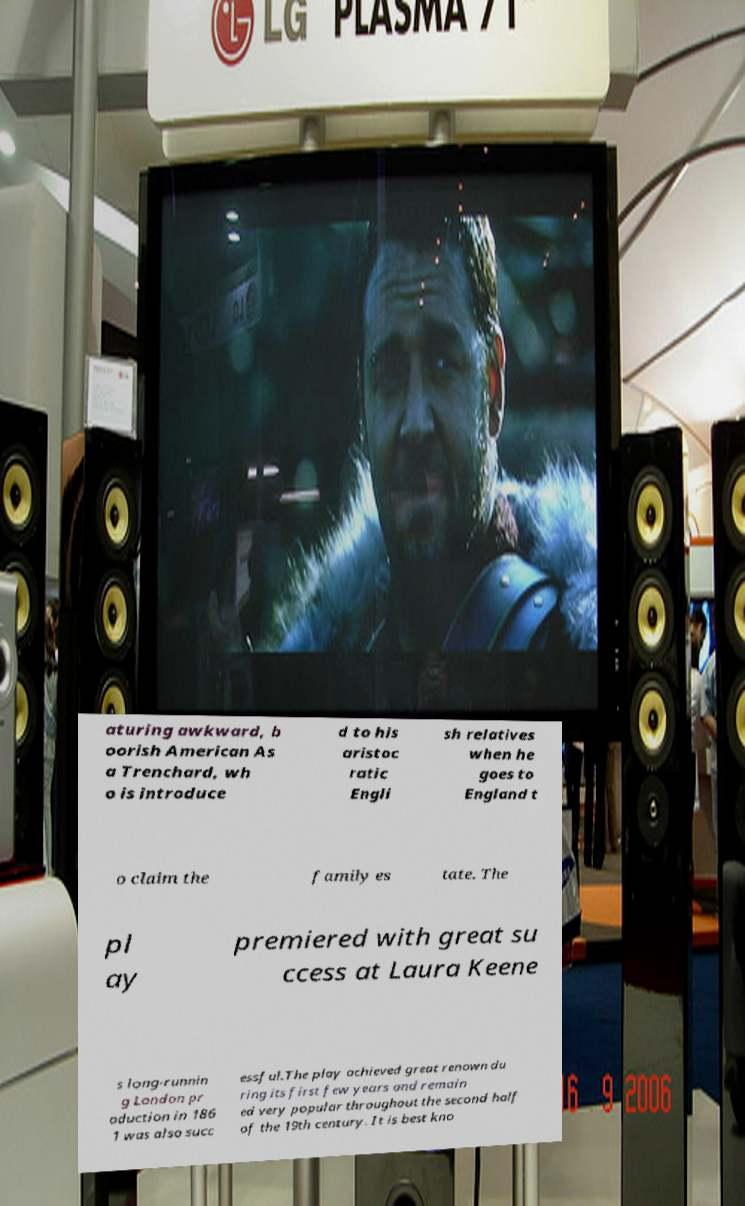Could you assist in decoding the text presented in this image and type it out clearly? aturing awkward, b oorish American As a Trenchard, wh o is introduce d to his aristoc ratic Engli sh relatives when he goes to England t o claim the family es tate. The pl ay premiered with great su ccess at Laura Keene s long-runnin g London pr oduction in 186 1 was also succ essful.The play achieved great renown du ring its first few years and remain ed very popular throughout the second half of the 19th century. It is best kno 